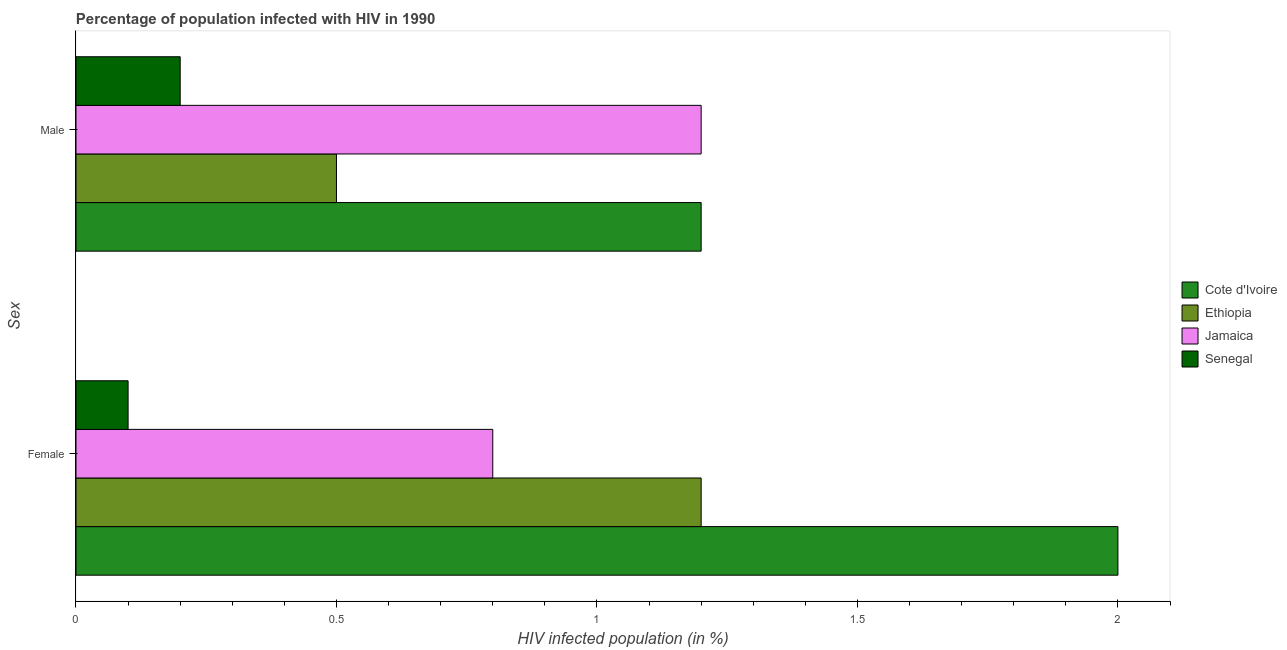How many different coloured bars are there?
Keep it short and to the point. 4. Are the number of bars on each tick of the Y-axis equal?
Your response must be concise. Yes. In which country was the percentage of males who are infected with hiv maximum?
Provide a succinct answer. Cote d'Ivoire. In which country was the percentage of females who are infected with hiv minimum?
Give a very brief answer. Senegal. What is the difference between the percentage of females who are infected with hiv in Jamaica and that in Ethiopia?
Offer a very short reply. -0.4. What is the difference between the percentage of males who are infected with hiv in Senegal and the percentage of females who are infected with hiv in Jamaica?
Give a very brief answer. -0.6. What is the average percentage of females who are infected with hiv per country?
Keep it short and to the point. 1.02. What is the difference between the percentage of females who are infected with hiv and percentage of males who are infected with hiv in Jamaica?
Provide a succinct answer. -0.4. What is the ratio of the percentage of males who are infected with hiv in Ethiopia to that in Cote d'Ivoire?
Make the answer very short. 0.42. In how many countries, is the percentage of males who are infected with hiv greater than the average percentage of males who are infected with hiv taken over all countries?
Offer a very short reply. 2. What does the 4th bar from the top in Female represents?
Your answer should be very brief. Cote d'Ivoire. What does the 1st bar from the bottom in Female represents?
Keep it short and to the point. Cote d'Ivoire. What is the difference between two consecutive major ticks on the X-axis?
Keep it short and to the point. 0.5. Does the graph contain grids?
Your answer should be compact. No. Where does the legend appear in the graph?
Ensure brevity in your answer.  Center right. How many legend labels are there?
Provide a succinct answer. 4. How are the legend labels stacked?
Make the answer very short. Vertical. What is the title of the graph?
Make the answer very short. Percentage of population infected with HIV in 1990. Does "Netherlands" appear as one of the legend labels in the graph?
Keep it short and to the point. No. What is the label or title of the X-axis?
Keep it short and to the point. HIV infected population (in %). What is the label or title of the Y-axis?
Offer a terse response. Sex. What is the HIV infected population (in %) in Ethiopia in Female?
Offer a terse response. 1.2. What is the HIV infected population (in %) in Jamaica in Female?
Make the answer very short. 0.8. What is the HIV infected population (in %) of Cote d'Ivoire in Male?
Offer a very short reply. 1.2. What is the HIV infected population (in %) in Ethiopia in Male?
Your answer should be very brief. 0.5. What is the HIV infected population (in %) in Senegal in Male?
Keep it short and to the point. 0.2. Across all Sex, what is the maximum HIV infected population (in %) in Cote d'Ivoire?
Your response must be concise. 2. Across all Sex, what is the maximum HIV infected population (in %) in Ethiopia?
Your answer should be compact. 1.2. Across all Sex, what is the maximum HIV infected population (in %) of Jamaica?
Make the answer very short. 1.2. Across all Sex, what is the minimum HIV infected population (in %) in Ethiopia?
Ensure brevity in your answer.  0.5. Across all Sex, what is the minimum HIV infected population (in %) in Senegal?
Offer a very short reply. 0.1. What is the total HIV infected population (in %) of Jamaica in the graph?
Your answer should be very brief. 2. What is the difference between the HIV infected population (in %) of Cote d'Ivoire in Female and that in Male?
Give a very brief answer. 0.8. What is the difference between the HIV infected population (in %) of Ethiopia in Female and that in Male?
Provide a short and direct response. 0.7. What is the difference between the HIV infected population (in %) in Jamaica in Female and that in Male?
Make the answer very short. -0.4. What is the difference between the HIV infected population (in %) of Senegal in Female and that in Male?
Your answer should be compact. -0.1. What is the difference between the HIV infected population (in %) of Cote d'Ivoire in Female and the HIV infected population (in %) of Senegal in Male?
Keep it short and to the point. 1.8. What is the difference between the HIV infected population (in %) in Ethiopia in Female and the HIV infected population (in %) in Jamaica in Male?
Provide a succinct answer. 0. What is the difference between the HIV infected population (in %) in Ethiopia in Female and the HIV infected population (in %) in Senegal in Male?
Ensure brevity in your answer.  1. What is the average HIV infected population (in %) of Jamaica per Sex?
Ensure brevity in your answer.  1. What is the average HIV infected population (in %) in Senegal per Sex?
Make the answer very short. 0.15. What is the difference between the HIV infected population (in %) in Ethiopia and HIV infected population (in %) in Jamaica in Female?
Your response must be concise. 0.4. What is the difference between the HIV infected population (in %) in Ethiopia and HIV infected population (in %) in Senegal in Female?
Your response must be concise. 1.1. What is the difference between the HIV infected population (in %) of Jamaica and HIV infected population (in %) of Senegal in Female?
Provide a short and direct response. 0.7. What is the difference between the HIV infected population (in %) in Cote d'Ivoire and HIV infected population (in %) in Ethiopia in Male?
Your response must be concise. 0.7. What is the difference between the HIV infected population (in %) of Cote d'Ivoire and HIV infected population (in %) of Jamaica in Male?
Offer a very short reply. 0. What is the difference between the HIV infected population (in %) in Cote d'Ivoire and HIV infected population (in %) in Senegal in Male?
Your response must be concise. 1. What is the difference between the HIV infected population (in %) of Ethiopia and HIV infected population (in %) of Jamaica in Male?
Keep it short and to the point. -0.7. What is the difference between the HIV infected population (in %) in Ethiopia and HIV infected population (in %) in Senegal in Male?
Provide a succinct answer. 0.3. What is the difference between the HIV infected population (in %) of Jamaica and HIV infected population (in %) of Senegal in Male?
Make the answer very short. 1. What is the ratio of the HIV infected population (in %) in Cote d'Ivoire in Female to that in Male?
Offer a very short reply. 1.67. What is the ratio of the HIV infected population (in %) in Ethiopia in Female to that in Male?
Provide a short and direct response. 2.4. What is the difference between the highest and the second highest HIV infected population (in %) of Ethiopia?
Provide a succinct answer. 0.7. What is the difference between the highest and the second highest HIV infected population (in %) of Jamaica?
Keep it short and to the point. 0.4. What is the difference between the highest and the lowest HIV infected population (in %) of Cote d'Ivoire?
Make the answer very short. 0.8. 